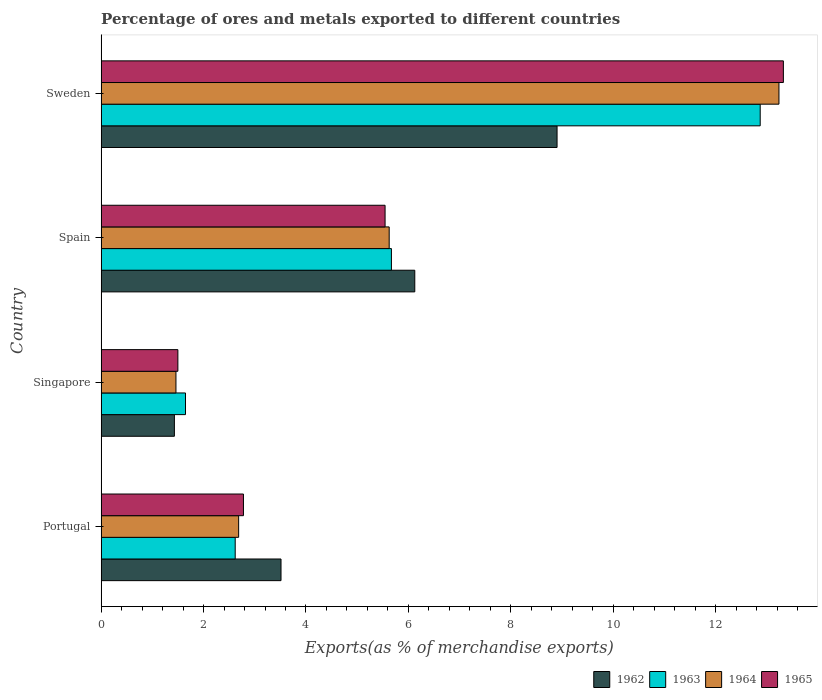How many groups of bars are there?
Provide a succinct answer. 4. Are the number of bars on each tick of the Y-axis equal?
Offer a very short reply. Yes. What is the label of the 1st group of bars from the top?
Provide a short and direct response. Sweden. What is the percentage of exports to different countries in 1962 in Spain?
Offer a terse response. 6.13. Across all countries, what is the maximum percentage of exports to different countries in 1963?
Provide a succinct answer. 12.87. Across all countries, what is the minimum percentage of exports to different countries in 1963?
Your answer should be very brief. 1.65. In which country was the percentage of exports to different countries in 1963 minimum?
Your answer should be compact. Singapore. What is the total percentage of exports to different countries in 1965 in the graph?
Provide a short and direct response. 23.15. What is the difference between the percentage of exports to different countries in 1962 in Singapore and that in Sweden?
Provide a succinct answer. -7.47. What is the difference between the percentage of exports to different countries in 1964 in Singapore and the percentage of exports to different countries in 1963 in Spain?
Provide a succinct answer. -4.21. What is the average percentage of exports to different countries in 1964 per country?
Keep it short and to the point. 5.75. What is the difference between the percentage of exports to different countries in 1965 and percentage of exports to different countries in 1964 in Portugal?
Your answer should be very brief. 0.09. What is the ratio of the percentage of exports to different countries in 1963 in Portugal to that in Spain?
Provide a short and direct response. 0.46. Is the percentage of exports to different countries in 1962 in Portugal less than that in Spain?
Give a very brief answer. Yes. Is the difference between the percentage of exports to different countries in 1965 in Portugal and Spain greater than the difference between the percentage of exports to different countries in 1964 in Portugal and Spain?
Offer a terse response. Yes. What is the difference between the highest and the second highest percentage of exports to different countries in 1965?
Your answer should be very brief. 7.78. What is the difference between the highest and the lowest percentage of exports to different countries in 1963?
Provide a short and direct response. 11.22. Is the sum of the percentage of exports to different countries in 1965 in Singapore and Sweden greater than the maximum percentage of exports to different countries in 1964 across all countries?
Offer a terse response. Yes. What does the 3rd bar from the top in Portugal represents?
Give a very brief answer. 1963. What does the 2nd bar from the bottom in Portugal represents?
Make the answer very short. 1963. How many bars are there?
Offer a terse response. 16. How many countries are there in the graph?
Provide a succinct answer. 4. How many legend labels are there?
Keep it short and to the point. 4. How are the legend labels stacked?
Keep it short and to the point. Horizontal. What is the title of the graph?
Give a very brief answer. Percentage of ores and metals exported to different countries. What is the label or title of the X-axis?
Your answer should be compact. Exports(as % of merchandise exports). What is the Exports(as % of merchandise exports) of 1962 in Portugal?
Keep it short and to the point. 3.51. What is the Exports(as % of merchandise exports) of 1963 in Portugal?
Offer a terse response. 2.62. What is the Exports(as % of merchandise exports) of 1964 in Portugal?
Offer a terse response. 2.69. What is the Exports(as % of merchandise exports) of 1965 in Portugal?
Provide a short and direct response. 2.78. What is the Exports(as % of merchandise exports) in 1962 in Singapore?
Offer a terse response. 1.43. What is the Exports(as % of merchandise exports) in 1963 in Singapore?
Give a very brief answer. 1.65. What is the Exports(as % of merchandise exports) of 1964 in Singapore?
Give a very brief answer. 1.46. What is the Exports(as % of merchandise exports) of 1965 in Singapore?
Provide a short and direct response. 1.5. What is the Exports(as % of merchandise exports) of 1962 in Spain?
Your answer should be compact. 6.13. What is the Exports(as % of merchandise exports) in 1963 in Spain?
Ensure brevity in your answer.  5.67. What is the Exports(as % of merchandise exports) in 1964 in Spain?
Keep it short and to the point. 5.63. What is the Exports(as % of merchandise exports) in 1965 in Spain?
Your answer should be very brief. 5.55. What is the Exports(as % of merchandise exports) in 1962 in Sweden?
Your answer should be compact. 8.9. What is the Exports(as % of merchandise exports) of 1963 in Sweden?
Your answer should be very brief. 12.87. What is the Exports(as % of merchandise exports) in 1964 in Sweden?
Your answer should be compact. 13.24. What is the Exports(as % of merchandise exports) in 1965 in Sweden?
Your answer should be very brief. 13.32. Across all countries, what is the maximum Exports(as % of merchandise exports) in 1962?
Give a very brief answer. 8.9. Across all countries, what is the maximum Exports(as % of merchandise exports) in 1963?
Make the answer very short. 12.87. Across all countries, what is the maximum Exports(as % of merchandise exports) of 1964?
Offer a very short reply. 13.24. Across all countries, what is the maximum Exports(as % of merchandise exports) of 1965?
Provide a succinct answer. 13.32. Across all countries, what is the minimum Exports(as % of merchandise exports) in 1962?
Your answer should be very brief. 1.43. Across all countries, what is the minimum Exports(as % of merchandise exports) of 1963?
Offer a terse response. 1.65. Across all countries, what is the minimum Exports(as % of merchandise exports) in 1964?
Offer a very short reply. 1.46. Across all countries, what is the minimum Exports(as % of merchandise exports) of 1965?
Your answer should be compact. 1.5. What is the total Exports(as % of merchandise exports) of 1962 in the graph?
Give a very brief answer. 19.97. What is the total Exports(as % of merchandise exports) of 1963 in the graph?
Ensure brevity in your answer.  22.81. What is the total Exports(as % of merchandise exports) of 1964 in the graph?
Provide a succinct answer. 23.01. What is the total Exports(as % of merchandise exports) of 1965 in the graph?
Your answer should be compact. 23.15. What is the difference between the Exports(as % of merchandise exports) of 1962 in Portugal and that in Singapore?
Your answer should be very brief. 2.08. What is the difference between the Exports(as % of merchandise exports) of 1963 in Portugal and that in Singapore?
Provide a short and direct response. 0.97. What is the difference between the Exports(as % of merchandise exports) in 1964 in Portugal and that in Singapore?
Provide a succinct answer. 1.22. What is the difference between the Exports(as % of merchandise exports) in 1965 in Portugal and that in Singapore?
Your answer should be very brief. 1.28. What is the difference between the Exports(as % of merchandise exports) in 1962 in Portugal and that in Spain?
Keep it short and to the point. -2.61. What is the difference between the Exports(as % of merchandise exports) of 1963 in Portugal and that in Spain?
Give a very brief answer. -3.05. What is the difference between the Exports(as % of merchandise exports) of 1964 in Portugal and that in Spain?
Provide a succinct answer. -2.94. What is the difference between the Exports(as % of merchandise exports) in 1965 in Portugal and that in Spain?
Offer a terse response. -2.77. What is the difference between the Exports(as % of merchandise exports) of 1962 in Portugal and that in Sweden?
Provide a succinct answer. -5.39. What is the difference between the Exports(as % of merchandise exports) of 1963 in Portugal and that in Sweden?
Your answer should be compact. -10.25. What is the difference between the Exports(as % of merchandise exports) in 1964 in Portugal and that in Sweden?
Your response must be concise. -10.55. What is the difference between the Exports(as % of merchandise exports) in 1965 in Portugal and that in Sweden?
Make the answer very short. -10.54. What is the difference between the Exports(as % of merchandise exports) in 1962 in Singapore and that in Spain?
Your answer should be very brief. -4.69. What is the difference between the Exports(as % of merchandise exports) in 1963 in Singapore and that in Spain?
Your response must be concise. -4.02. What is the difference between the Exports(as % of merchandise exports) in 1964 in Singapore and that in Spain?
Offer a very short reply. -4.16. What is the difference between the Exports(as % of merchandise exports) in 1965 in Singapore and that in Spain?
Give a very brief answer. -4.05. What is the difference between the Exports(as % of merchandise exports) in 1962 in Singapore and that in Sweden?
Your response must be concise. -7.47. What is the difference between the Exports(as % of merchandise exports) in 1963 in Singapore and that in Sweden?
Your response must be concise. -11.22. What is the difference between the Exports(as % of merchandise exports) of 1964 in Singapore and that in Sweden?
Provide a succinct answer. -11.78. What is the difference between the Exports(as % of merchandise exports) of 1965 in Singapore and that in Sweden?
Keep it short and to the point. -11.83. What is the difference between the Exports(as % of merchandise exports) of 1962 in Spain and that in Sweden?
Offer a terse response. -2.78. What is the difference between the Exports(as % of merchandise exports) in 1963 in Spain and that in Sweden?
Offer a terse response. -7.2. What is the difference between the Exports(as % of merchandise exports) in 1964 in Spain and that in Sweden?
Keep it short and to the point. -7.61. What is the difference between the Exports(as % of merchandise exports) of 1965 in Spain and that in Sweden?
Provide a short and direct response. -7.78. What is the difference between the Exports(as % of merchandise exports) in 1962 in Portugal and the Exports(as % of merchandise exports) in 1963 in Singapore?
Provide a succinct answer. 1.87. What is the difference between the Exports(as % of merchandise exports) in 1962 in Portugal and the Exports(as % of merchandise exports) in 1964 in Singapore?
Ensure brevity in your answer.  2.05. What is the difference between the Exports(as % of merchandise exports) of 1962 in Portugal and the Exports(as % of merchandise exports) of 1965 in Singapore?
Provide a short and direct response. 2.01. What is the difference between the Exports(as % of merchandise exports) in 1963 in Portugal and the Exports(as % of merchandise exports) in 1964 in Singapore?
Your answer should be compact. 1.16. What is the difference between the Exports(as % of merchandise exports) of 1963 in Portugal and the Exports(as % of merchandise exports) of 1965 in Singapore?
Provide a succinct answer. 1.12. What is the difference between the Exports(as % of merchandise exports) of 1964 in Portugal and the Exports(as % of merchandise exports) of 1965 in Singapore?
Your response must be concise. 1.19. What is the difference between the Exports(as % of merchandise exports) of 1962 in Portugal and the Exports(as % of merchandise exports) of 1963 in Spain?
Provide a succinct answer. -2.16. What is the difference between the Exports(as % of merchandise exports) of 1962 in Portugal and the Exports(as % of merchandise exports) of 1964 in Spain?
Offer a terse response. -2.11. What is the difference between the Exports(as % of merchandise exports) of 1962 in Portugal and the Exports(as % of merchandise exports) of 1965 in Spain?
Offer a very short reply. -2.03. What is the difference between the Exports(as % of merchandise exports) in 1963 in Portugal and the Exports(as % of merchandise exports) in 1964 in Spain?
Make the answer very short. -3.01. What is the difference between the Exports(as % of merchandise exports) of 1963 in Portugal and the Exports(as % of merchandise exports) of 1965 in Spain?
Offer a terse response. -2.93. What is the difference between the Exports(as % of merchandise exports) in 1964 in Portugal and the Exports(as % of merchandise exports) in 1965 in Spain?
Your response must be concise. -2.86. What is the difference between the Exports(as % of merchandise exports) of 1962 in Portugal and the Exports(as % of merchandise exports) of 1963 in Sweden?
Keep it short and to the point. -9.36. What is the difference between the Exports(as % of merchandise exports) of 1962 in Portugal and the Exports(as % of merchandise exports) of 1964 in Sweden?
Provide a short and direct response. -9.72. What is the difference between the Exports(as % of merchandise exports) in 1962 in Portugal and the Exports(as % of merchandise exports) in 1965 in Sweden?
Keep it short and to the point. -9.81. What is the difference between the Exports(as % of merchandise exports) in 1963 in Portugal and the Exports(as % of merchandise exports) in 1964 in Sweden?
Make the answer very short. -10.62. What is the difference between the Exports(as % of merchandise exports) in 1963 in Portugal and the Exports(as % of merchandise exports) in 1965 in Sweden?
Provide a succinct answer. -10.71. What is the difference between the Exports(as % of merchandise exports) in 1964 in Portugal and the Exports(as % of merchandise exports) in 1965 in Sweden?
Your answer should be very brief. -10.64. What is the difference between the Exports(as % of merchandise exports) of 1962 in Singapore and the Exports(as % of merchandise exports) of 1963 in Spain?
Give a very brief answer. -4.24. What is the difference between the Exports(as % of merchandise exports) in 1962 in Singapore and the Exports(as % of merchandise exports) in 1964 in Spain?
Make the answer very short. -4.2. What is the difference between the Exports(as % of merchandise exports) of 1962 in Singapore and the Exports(as % of merchandise exports) of 1965 in Spain?
Provide a succinct answer. -4.11. What is the difference between the Exports(as % of merchandise exports) of 1963 in Singapore and the Exports(as % of merchandise exports) of 1964 in Spain?
Your answer should be compact. -3.98. What is the difference between the Exports(as % of merchandise exports) of 1963 in Singapore and the Exports(as % of merchandise exports) of 1965 in Spain?
Offer a very short reply. -3.9. What is the difference between the Exports(as % of merchandise exports) in 1964 in Singapore and the Exports(as % of merchandise exports) in 1965 in Spain?
Your response must be concise. -4.08. What is the difference between the Exports(as % of merchandise exports) of 1962 in Singapore and the Exports(as % of merchandise exports) of 1963 in Sweden?
Your answer should be compact. -11.44. What is the difference between the Exports(as % of merchandise exports) of 1962 in Singapore and the Exports(as % of merchandise exports) of 1964 in Sweden?
Your response must be concise. -11.81. What is the difference between the Exports(as % of merchandise exports) in 1962 in Singapore and the Exports(as % of merchandise exports) in 1965 in Sweden?
Make the answer very short. -11.89. What is the difference between the Exports(as % of merchandise exports) of 1963 in Singapore and the Exports(as % of merchandise exports) of 1964 in Sweden?
Offer a terse response. -11.59. What is the difference between the Exports(as % of merchandise exports) in 1963 in Singapore and the Exports(as % of merchandise exports) in 1965 in Sweden?
Your answer should be compact. -11.68. What is the difference between the Exports(as % of merchandise exports) of 1964 in Singapore and the Exports(as % of merchandise exports) of 1965 in Sweden?
Offer a very short reply. -11.86. What is the difference between the Exports(as % of merchandise exports) in 1962 in Spain and the Exports(as % of merchandise exports) in 1963 in Sweden?
Offer a terse response. -6.75. What is the difference between the Exports(as % of merchandise exports) in 1962 in Spain and the Exports(as % of merchandise exports) in 1964 in Sweden?
Provide a short and direct response. -7.11. What is the difference between the Exports(as % of merchandise exports) in 1962 in Spain and the Exports(as % of merchandise exports) in 1965 in Sweden?
Keep it short and to the point. -7.2. What is the difference between the Exports(as % of merchandise exports) of 1963 in Spain and the Exports(as % of merchandise exports) of 1964 in Sweden?
Provide a succinct answer. -7.57. What is the difference between the Exports(as % of merchandise exports) of 1963 in Spain and the Exports(as % of merchandise exports) of 1965 in Sweden?
Your answer should be compact. -7.65. What is the difference between the Exports(as % of merchandise exports) of 1964 in Spain and the Exports(as % of merchandise exports) of 1965 in Sweden?
Your response must be concise. -7.7. What is the average Exports(as % of merchandise exports) of 1962 per country?
Ensure brevity in your answer.  4.99. What is the average Exports(as % of merchandise exports) of 1963 per country?
Your response must be concise. 5.7. What is the average Exports(as % of merchandise exports) in 1964 per country?
Ensure brevity in your answer.  5.75. What is the average Exports(as % of merchandise exports) in 1965 per country?
Your answer should be very brief. 5.79. What is the difference between the Exports(as % of merchandise exports) in 1962 and Exports(as % of merchandise exports) in 1963 in Portugal?
Give a very brief answer. 0.89. What is the difference between the Exports(as % of merchandise exports) in 1962 and Exports(as % of merchandise exports) in 1964 in Portugal?
Your answer should be very brief. 0.83. What is the difference between the Exports(as % of merchandise exports) of 1962 and Exports(as % of merchandise exports) of 1965 in Portugal?
Your answer should be very brief. 0.73. What is the difference between the Exports(as % of merchandise exports) in 1963 and Exports(as % of merchandise exports) in 1964 in Portugal?
Offer a terse response. -0.07. What is the difference between the Exports(as % of merchandise exports) of 1963 and Exports(as % of merchandise exports) of 1965 in Portugal?
Provide a short and direct response. -0.16. What is the difference between the Exports(as % of merchandise exports) in 1964 and Exports(as % of merchandise exports) in 1965 in Portugal?
Keep it short and to the point. -0.09. What is the difference between the Exports(as % of merchandise exports) in 1962 and Exports(as % of merchandise exports) in 1963 in Singapore?
Ensure brevity in your answer.  -0.22. What is the difference between the Exports(as % of merchandise exports) in 1962 and Exports(as % of merchandise exports) in 1964 in Singapore?
Your answer should be very brief. -0.03. What is the difference between the Exports(as % of merchandise exports) in 1962 and Exports(as % of merchandise exports) in 1965 in Singapore?
Provide a succinct answer. -0.07. What is the difference between the Exports(as % of merchandise exports) in 1963 and Exports(as % of merchandise exports) in 1964 in Singapore?
Give a very brief answer. 0.19. What is the difference between the Exports(as % of merchandise exports) of 1963 and Exports(as % of merchandise exports) of 1965 in Singapore?
Your answer should be compact. 0.15. What is the difference between the Exports(as % of merchandise exports) of 1964 and Exports(as % of merchandise exports) of 1965 in Singapore?
Give a very brief answer. -0.04. What is the difference between the Exports(as % of merchandise exports) of 1962 and Exports(as % of merchandise exports) of 1963 in Spain?
Offer a very short reply. 0.46. What is the difference between the Exports(as % of merchandise exports) in 1962 and Exports(as % of merchandise exports) in 1964 in Spain?
Your answer should be very brief. 0.5. What is the difference between the Exports(as % of merchandise exports) of 1962 and Exports(as % of merchandise exports) of 1965 in Spain?
Provide a succinct answer. 0.58. What is the difference between the Exports(as % of merchandise exports) of 1963 and Exports(as % of merchandise exports) of 1964 in Spain?
Your response must be concise. 0.04. What is the difference between the Exports(as % of merchandise exports) in 1963 and Exports(as % of merchandise exports) in 1965 in Spain?
Keep it short and to the point. 0.12. What is the difference between the Exports(as % of merchandise exports) of 1964 and Exports(as % of merchandise exports) of 1965 in Spain?
Provide a short and direct response. 0.08. What is the difference between the Exports(as % of merchandise exports) in 1962 and Exports(as % of merchandise exports) in 1963 in Sweden?
Make the answer very short. -3.97. What is the difference between the Exports(as % of merchandise exports) in 1962 and Exports(as % of merchandise exports) in 1964 in Sweden?
Your answer should be compact. -4.33. What is the difference between the Exports(as % of merchandise exports) in 1962 and Exports(as % of merchandise exports) in 1965 in Sweden?
Ensure brevity in your answer.  -4.42. What is the difference between the Exports(as % of merchandise exports) in 1963 and Exports(as % of merchandise exports) in 1964 in Sweden?
Ensure brevity in your answer.  -0.37. What is the difference between the Exports(as % of merchandise exports) of 1963 and Exports(as % of merchandise exports) of 1965 in Sweden?
Keep it short and to the point. -0.45. What is the difference between the Exports(as % of merchandise exports) of 1964 and Exports(as % of merchandise exports) of 1965 in Sweden?
Offer a very short reply. -0.09. What is the ratio of the Exports(as % of merchandise exports) of 1962 in Portugal to that in Singapore?
Your response must be concise. 2.46. What is the ratio of the Exports(as % of merchandise exports) in 1963 in Portugal to that in Singapore?
Offer a very short reply. 1.59. What is the ratio of the Exports(as % of merchandise exports) of 1964 in Portugal to that in Singapore?
Give a very brief answer. 1.84. What is the ratio of the Exports(as % of merchandise exports) in 1965 in Portugal to that in Singapore?
Ensure brevity in your answer.  1.85. What is the ratio of the Exports(as % of merchandise exports) in 1962 in Portugal to that in Spain?
Provide a short and direct response. 0.57. What is the ratio of the Exports(as % of merchandise exports) of 1963 in Portugal to that in Spain?
Keep it short and to the point. 0.46. What is the ratio of the Exports(as % of merchandise exports) in 1964 in Portugal to that in Spain?
Offer a very short reply. 0.48. What is the ratio of the Exports(as % of merchandise exports) in 1965 in Portugal to that in Spain?
Your answer should be very brief. 0.5. What is the ratio of the Exports(as % of merchandise exports) of 1962 in Portugal to that in Sweden?
Give a very brief answer. 0.39. What is the ratio of the Exports(as % of merchandise exports) in 1963 in Portugal to that in Sweden?
Provide a short and direct response. 0.2. What is the ratio of the Exports(as % of merchandise exports) of 1964 in Portugal to that in Sweden?
Provide a short and direct response. 0.2. What is the ratio of the Exports(as % of merchandise exports) in 1965 in Portugal to that in Sweden?
Keep it short and to the point. 0.21. What is the ratio of the Exports(as % of merchandise exports) in 1962 in Singapore to that in Spain?
Make the answer very short. 0.23. What is the ratio of the Exports(as % of merchandise exports) in 1963 in Singapore to that in Spain?
Ensure brevity in your answer.  0.29. What is the ratio of the Exports(as % of merchandise exports) of 1964 in Singapore to that in Spain?
Give a very brief answer. 0.26. What is the ratio of the Exports(as % of merchandise exports) of 1965 in Singapore to that in Spain?
Your answer should be very brief. 0.27. What is the ratio of the Exports(as % of merchandise exports) of 1962 in Singapore to that in Sweden?
Keep it short and to the point. 0.16. What is the ratio of the Exports(as % of merchandise exports) in 1963 in Singapore to that in Sweden?
Your answer should be compact. 0.13. What is the ratio of the Exports(as % of merchandise exports) of 1964 in Singapore to that in Sweden?
Ensure brevity in your answer.  0.11. What is the ratio of the Exports(as % of merchandise exports) in 1965 in Singapore to that in Sweden?
Offer a terse response. 0.11. What is the ratio of the Exports(as % of merchandise exports) of 1962 in Spain to that in Sweden?
Offer a very short reply. 0.69. What is the ratio of the Exports(as % of merchandise exports) in 1963 in Spain to that in Sweden?
Offer a terse response. 0.44. What is the ratio of the Exports(as % of merchandise exports) in 1964 in Spain to that in Sweden?
Your answer should be very brief. 0.42. What is the ratio of the Exports(as % of merchandise exports) in 1965 in Spain to that in Sweden?
Make the answer very short. 0.42. What is the difference between the highest and the second highest Exports(as % of merchandise exports) in 1962?
Your answer should be very brief. 2.78. What is the difference between the highest and the second highest Exports(as % of merchandise exports) of 1963?
Offer a terse response. 7.2. What is the difference between the highest and the second highest Exports(as % of merchandise exports) in 1964?
Keep it short and to the point. 7.61. What is the difference between the highest and the second highest Exports(as % of merchandise exports) in 1965?
Provide a succinct answer. 7.78. What is the difference between the highest and the lowest Exports(as % of merchandise exports) in 1962?
Offer a terse response. 7.47. What is the difference between the highest and the lowest Exports(as % of merchandise exports) of 1963?
Keep it short and to the point. 11.22. What is the difference between the highest and the lowest Exports(as % of merchandise exports) of 1964?
Keep it short and to the point. 11.78. What is the difference between the highest and the lowest Exports(as % of merchandise exports) of 1965?
Offer a terse response. 11.83. 